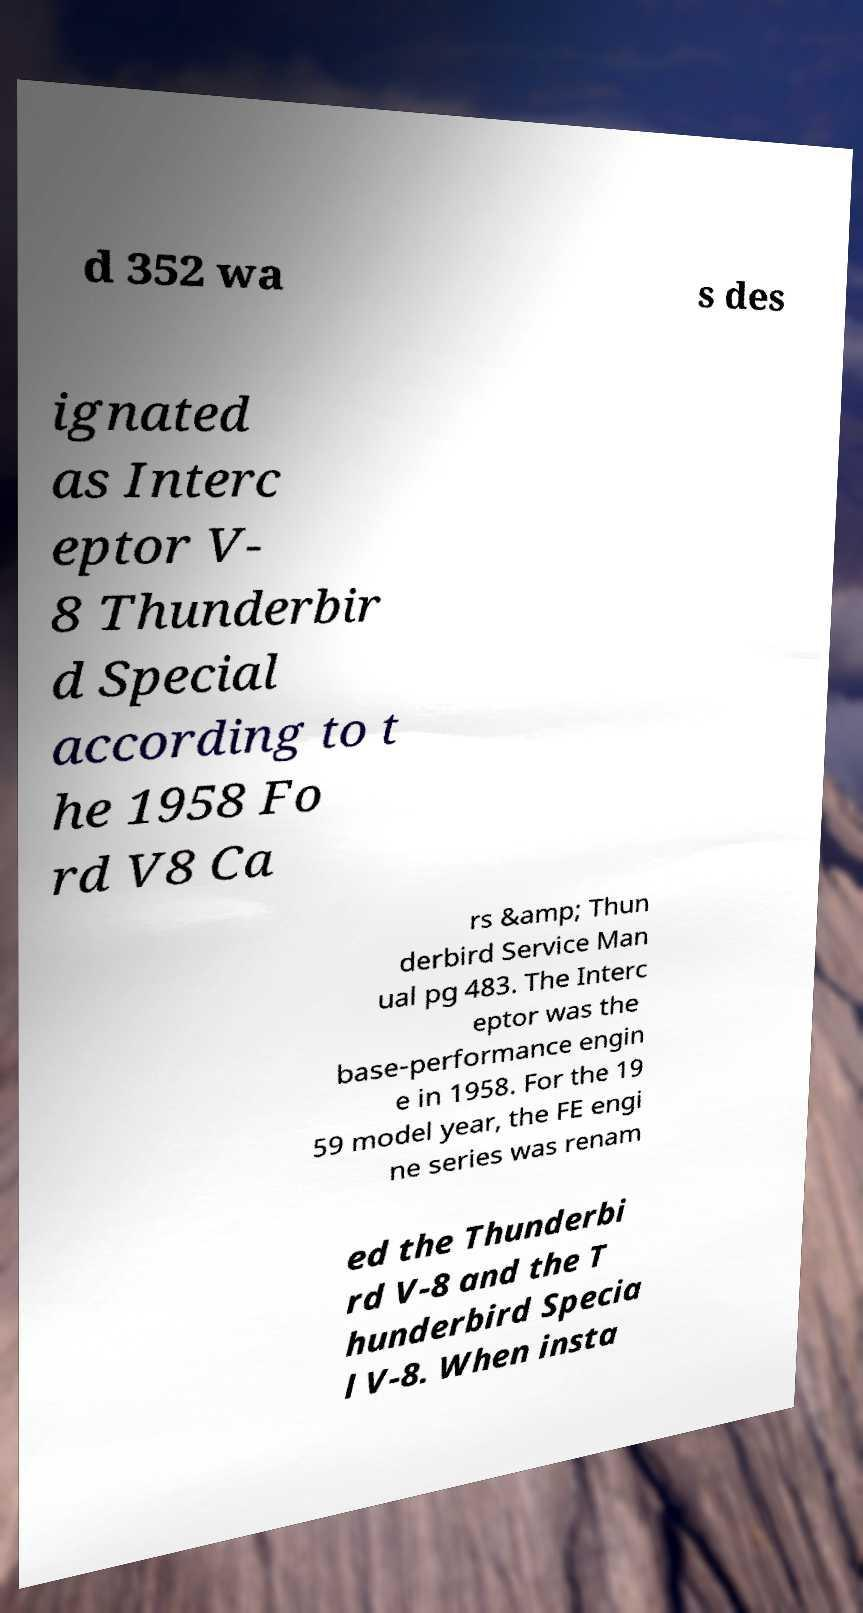There's text embedded in this image that I need extracted. Can you transcribe it verbatim? d 352 wa s des ignated as Interc eptor V- 8 Thunderbir d Special according to t he 1958 Fo rd V8 Ca rs &amp; Thun derbird Service Man ual pg 483. The Interc eptor was the base-performance engin e in 1958. For the 19 59 model year, the FE engi ne series was renam ed the Thunderbi rd V-8 and the T hunderbird Specia l V-8. When insta 